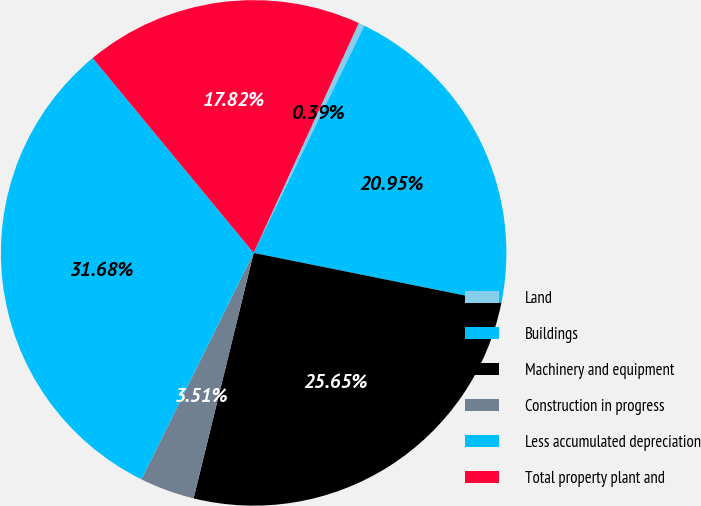<chart> <loc_0><loc_0><loc_500><loc_500><pie_chart><fcel>Land<fcel>Buildings<fcel>Machinery and equipment<fcel>Construction in progress<fcel>Less accumulated depreciation<fcel>Total property plant and<nl><fcel>0.39%<fcel>20.95%<fcel>25.65%<fcel>3.51%<fcel>31.68%<fcel>17.82%<nl></chart> 